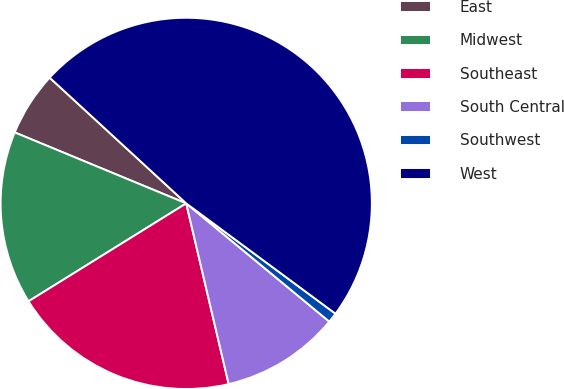Convert chart to OTSL. <chart><loc_0><loc_0><loc_500><loc_500><pie_chart><fcel>East<fcel>Midwest<fcel>Southeast<fcel>South Central<fcel>Southwest<fcel>West<nl><fcel>5.6%<fcel>15.09%<fcel>19.83%<fcel>10.34%<fcel>0.86%<fcel>48.29%<nl></chart> 